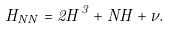Convert formula to latex. <formula><loc_0><loc_0><loc_500><loc_500>H _ { N N } = 2 H ^ { 3 } + N H + \nu .</formula> 